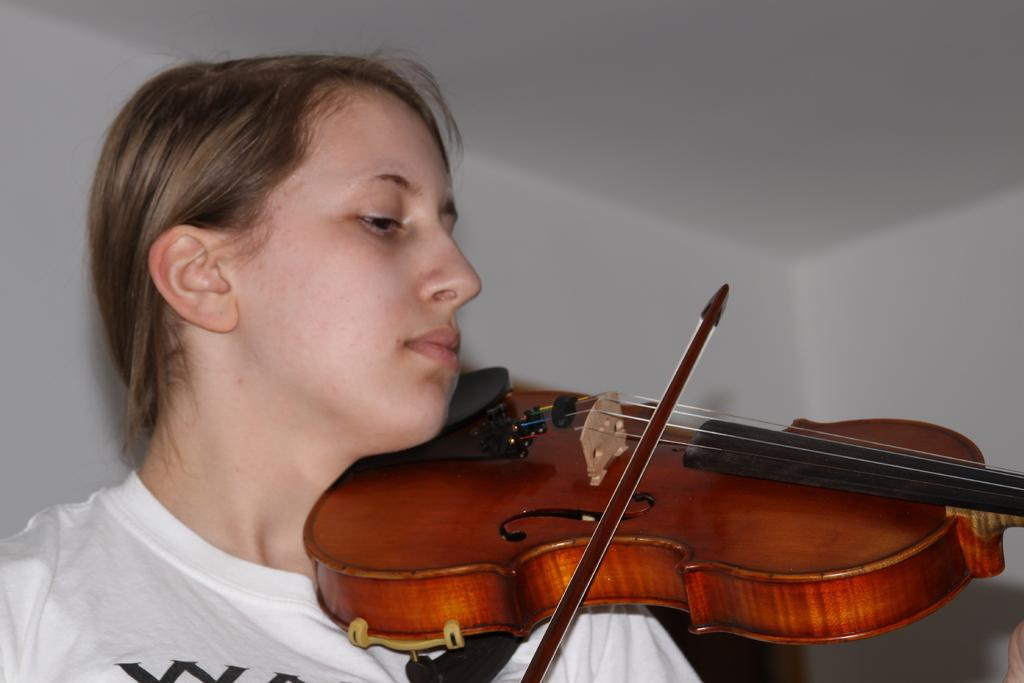What is the person in the image doing? The person is playing a violin. What can be seen in the background of the image? There is a wall in the background of the image. What type of fruit is the person holding while playing the violin in the image? There is no fruit present in the image; the person is only playing the violin. 